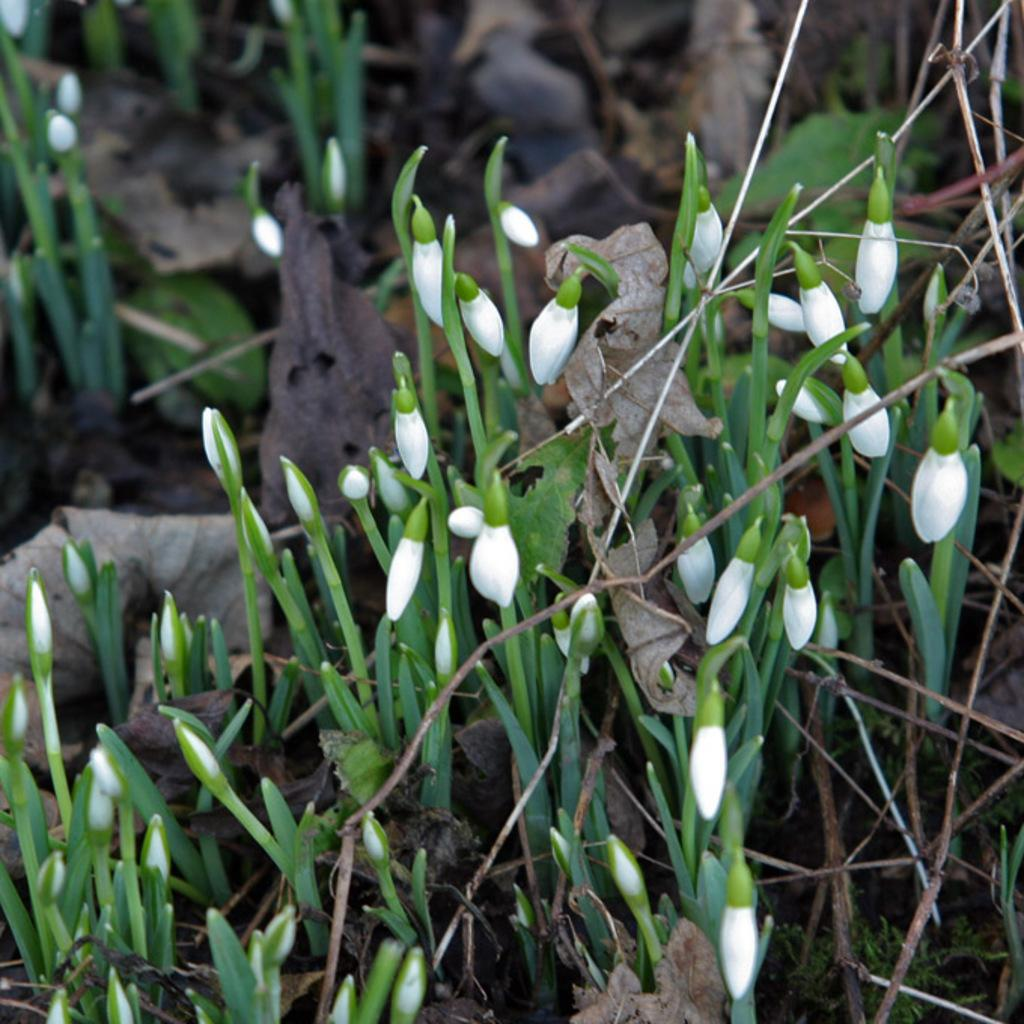What type of plants can be seen in the image? There are small plants in the image. What color are the flower buds on the plants? The flower buds on the plants are white. Are there any signs of aging or wilting on the plants? Yes, there are dried leaves visible in the image. What can be observed about the surrounding environment of the small plants? A: There are other plants near the small plants. How does the mass of the plants help in taking notes? The mass of the plants does not help in taking notes, as plants are not capable of taking notes. 